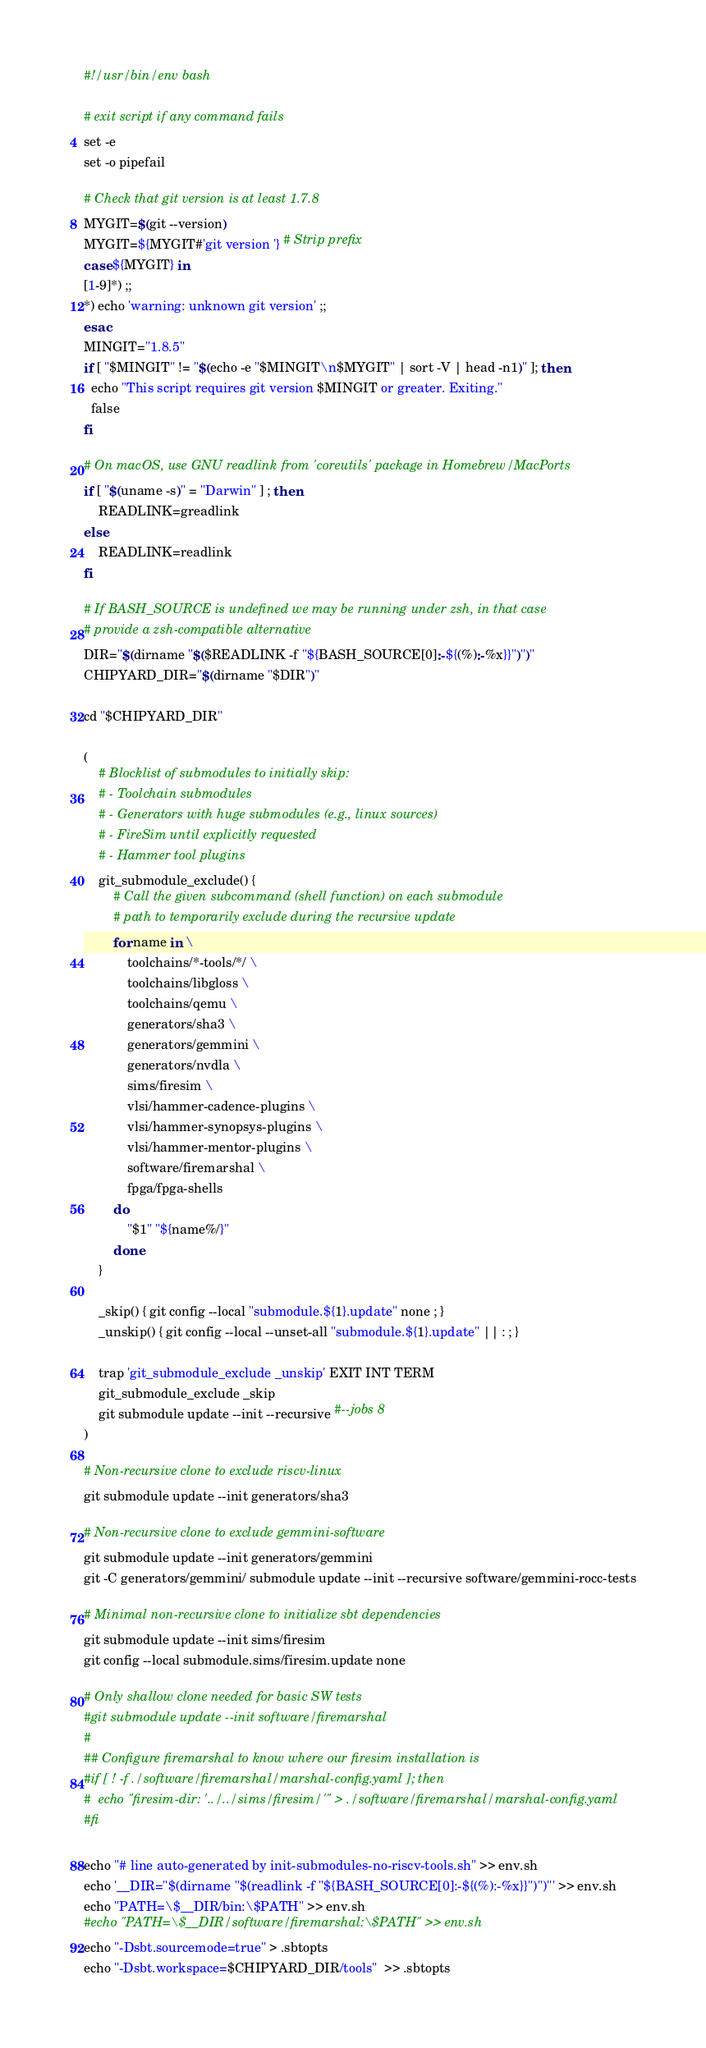<code> <loc_0><loc_0><loc_500><loc_500><_Bash_>#!/usr/bin/env bash

# exit script if any command fails
set -e
set -o pipefail

# Check that git version is at least 1.7.8
MYGIT=$(git --version)
MYGIT=${MYGIT#'git version '} # Strip prefix
case ${MYGIT} in
[1-9]*) ;;
*) echo 'warning: unknown git version' ;;
esac
MINGIT="1.8.5"
if [ "$MINGIT" != "$(echo -e "$MINGIT\n$MYGIT" | sort -V | head -n1)" ]; then
  echo "This script requires git version $MINGIT or greater. Exiting."
  false
fi

# On macOS, use GNU readlink from 'coreutils' package in Homebrew/MacPorts
if [ "$(uname -s)" = "Darwin" ] ; then
    READLINK=greadlink
else
    READLINK=readlink
fi

# If BASH_SOURCE is undefined we may be running under zsh, in that case
# provide a zsh-compatible alternative
DIR="$(dirname "$($READLINK -f "${BASH_SOURCE[0]:-${(%):-%x}}")")"
CHIPYARD_DIR="$(dirname "$DIR")"

cd "$CHIPYARD_DIR"

(
    # Blocklist of submodules to initially skip:
    # - Toolchain submodules
    # - Generators with huge submodules (e.g., linux sources)
    # - FireSim until explicitly requested
    # - Hammer tool plugins
    git_submodule_exclude() {
        # Call the given subcommand (shell function) on each submodule
        # path to temporarily exclude during the recursive update
        for name in \
            toolchains/*-tools/*/ \
            toolchains/libgloss \
            toolchains/qemu \
            generators/sha3 \
            generators/gemmini \
            generators/nvdla \
            sims/firesim \
            vlsi/hammer-cadence-plugins \
            vlsi/hammer-synopsys-plugins \
            vlsi/hammer-mentor-plugins \
            software/firemarshal \
            fpga/fpga-shells
        do
            "$1" "${name%/}"
        done
    }

    _skip() { git config --local "submodule.${1}.update" none ; }
    _unskip() { git config --local --unset-all "submodule.${1}.update" || : ; }

    trap 'git_submodule_exclude _unskip' EXIT INT TERM
    git_submodule_exclude _skip
    git submodule update --init --recursive #--jobs 8
)

# Non-recursive clone to exclude riscv-linux
git submodule update --init generators/sha3

# Non-recursive clone to exclude gemmini-software
git submodule update --init generators/gemmini
git -C generators/gemmini/ submodule update --init --recursive software/gemmini-rocc-tests

# Minimal non-recursive clone to initialize sbt dependencies
git submodule update --init sims/firesim
git config --local submodule.sims/firesim.update none

# Only shallow clone needed for basic SW tests
#git submodule update --init software/firemarshal
#
## Configure firemarshal to know where our firesim installation is
#if [ ! -f ./software/firemarshal/marshal-config.yaml ]; then
#  echo "firesim-dir: '../../sims/firesim/'" > ./software/firemarshal/marshal-config.yaml
#fi

echo "# line auto-generated by init-submodules-no-riscv-tools.sh" >> env.sh
echo '__DIR="$(dirname "$(readlink -f "${BASH_SOURCE[0]:-${(%):-%x}}")")"' >> env.sh
echo "PATH=\$__DIR/bin:\$PATH" >> env.sh
#echo "PATH=\$__DIR/software/firemarshal:\$PATH" >> env.sh
echo "-Dsbt.sourcemode=true" > .sbtopts
echo "-Dsbt.workspace=$CHIPYARD_DIR/tools"  >> .sbtopts
</code> 